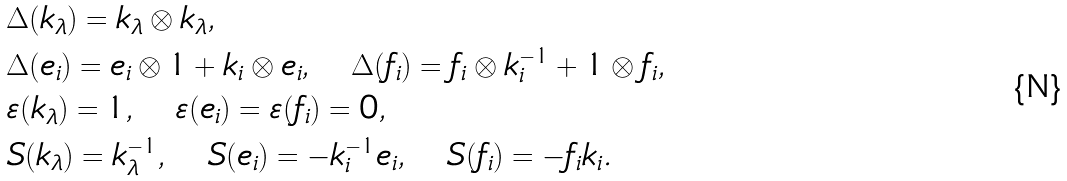<formula> <loc_0><loc_0><loc_500><loc_500>& \Delta ( k _ { \lambda } ) = k _ { \lambda } \otimes k _ { \lambda } , \\ & \Delta ( e _ { i } ) = e _ { i } \otimes 1 + k _ { i } \otimes e _ { i } , \quad \Delta ( f _ { i } ) = f _ { i } \otimes k _ { i } ^ { - 1 } + 1 \otimes f _ { i } , \\ & \varepsilon ( k _ { \lambda } ) = 1 , \quad \varepsilon ( e _ { i } ) = \varepsilon ( f _ { i } ) = 0 , \\ & S ( k _ { \lambda } ) = k _ { \lambda } ^ { - 1 } , \quad S ( e _ { i } ) = - k _ { i } ^ { - 1 } e _ { i } , \quad S ( f _ { i } ) = - f _ { i } k _ { i } .</formula> 